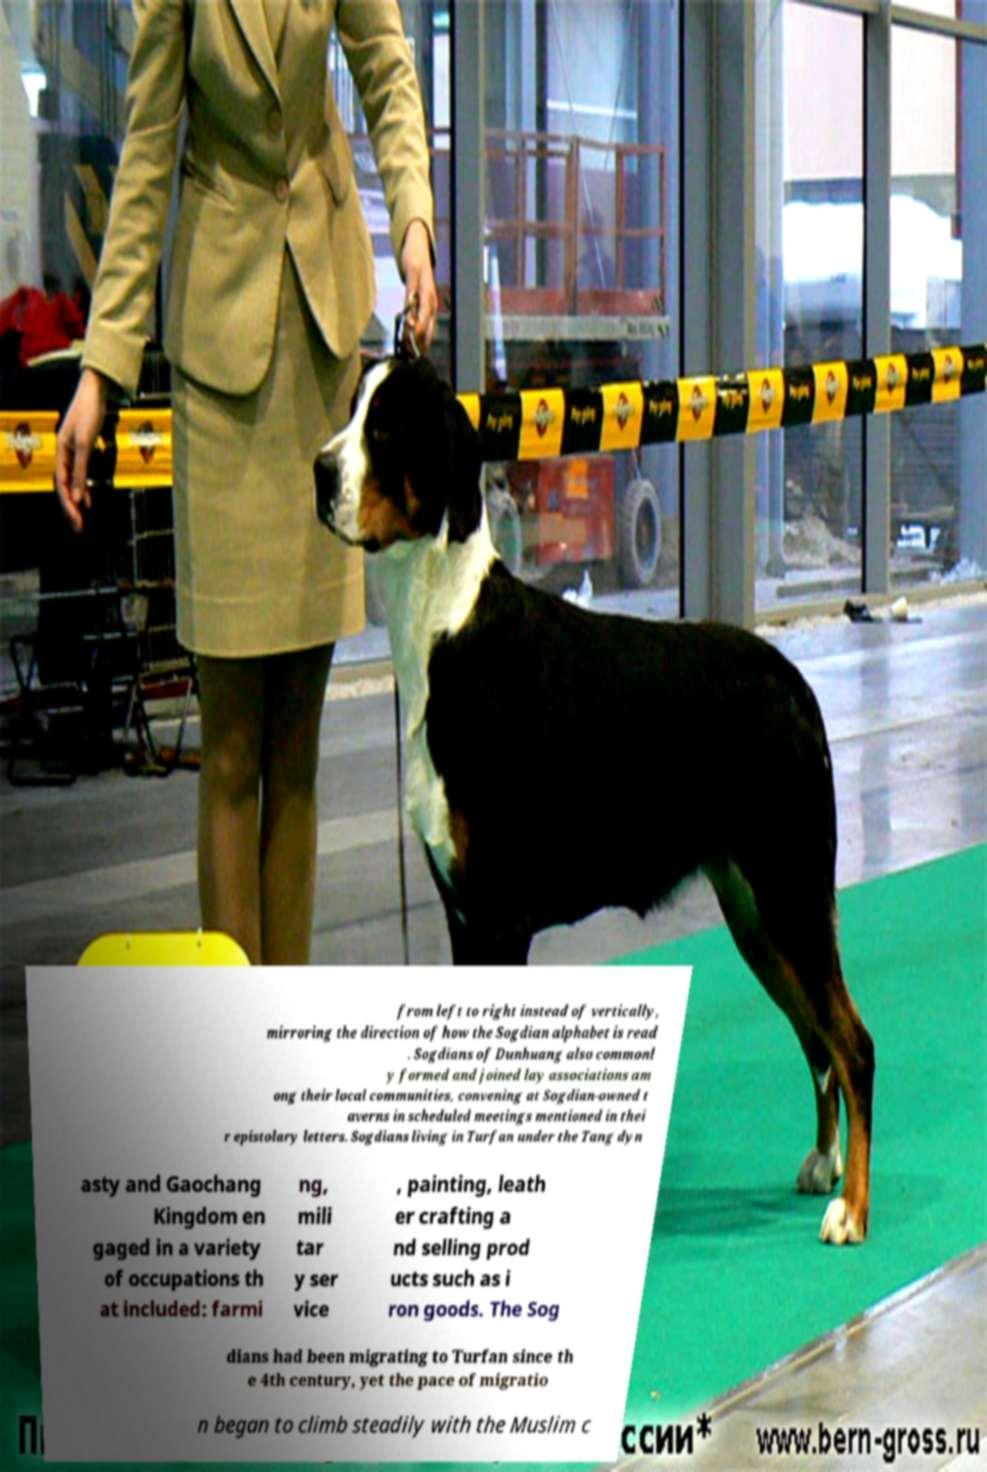Could you assist in decoding the text presented in this image and type it out clearly? from left to right instead of vertically, mirroring the direction of how the Sogdian alphabet is read . Sogdians of Dunhuang also commonl y formed and joined lay associations am ong their local communities, convening at Sogdian-owned t averns in scheduled meetings mentioned in thei r epistolary letters. Sogdians living in Turfan under the Tang dyn asty and Gaochang Kingdom en gaged in a variety of occupations th at included: farmi ng, mili tar y ser vice , painting, leath er crafting a nd selling prod ucts such as i ron goods. The Sog dians had been migrating to Turfan since th e 4th century, yet the pace of migratio n began to climb steadily with the Muslim c 